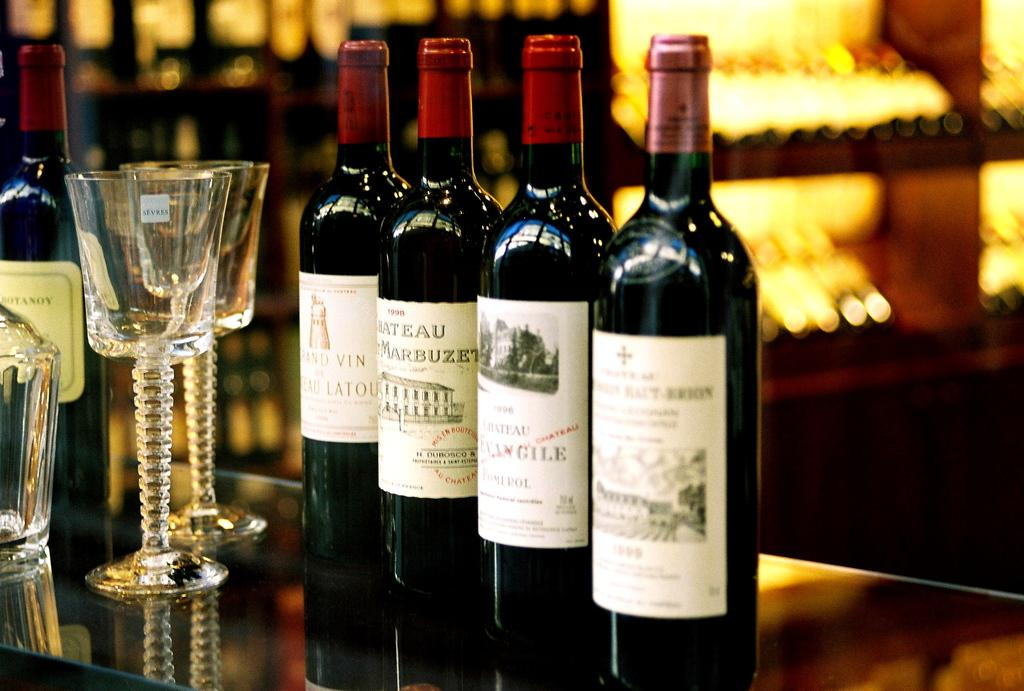<image>
Create a compact narrative representing the image presented. A bottle of 1998 Marbuzet sits on a table with several other bottles of wine 